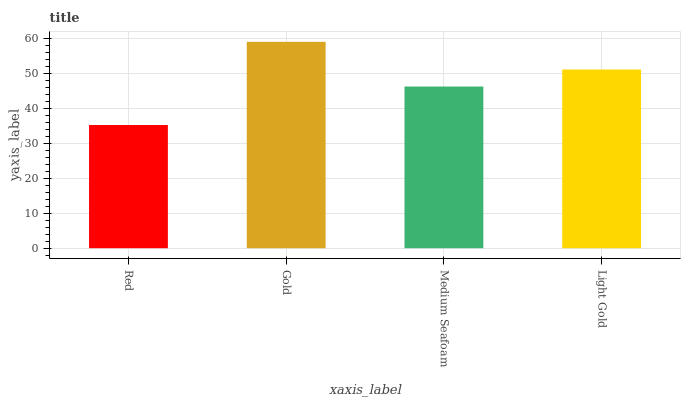Is Red the minimum?
Answer yes or no. Yes. Is Gold the maximum?
Answer yes or no. Yes. Is Medium Seafoam the minimum?
Answer yes or no. No. Is Medium Seafoam the maximum?
Answer yes or no. No. Is Gold greater than Medium Seafoam?
Answer yes or no. Yes. Is Medium Seafoam less than Gold?
Answer yes or no. Yes. Is Medium Seafoam greater than Gold?
Answer yes or no. No. Is Gold less than Medium Seafoam?
Answer yes or no. No. Is Light Gold the high median?
Answer yes or no. Yes. Is Medium Seafoam the low median?
Answer yes or no. Yes. Is Medium Seafoam the high median?
Answer yes or no. No. Is Light Gold the low median?
Answer yes or no. No. 